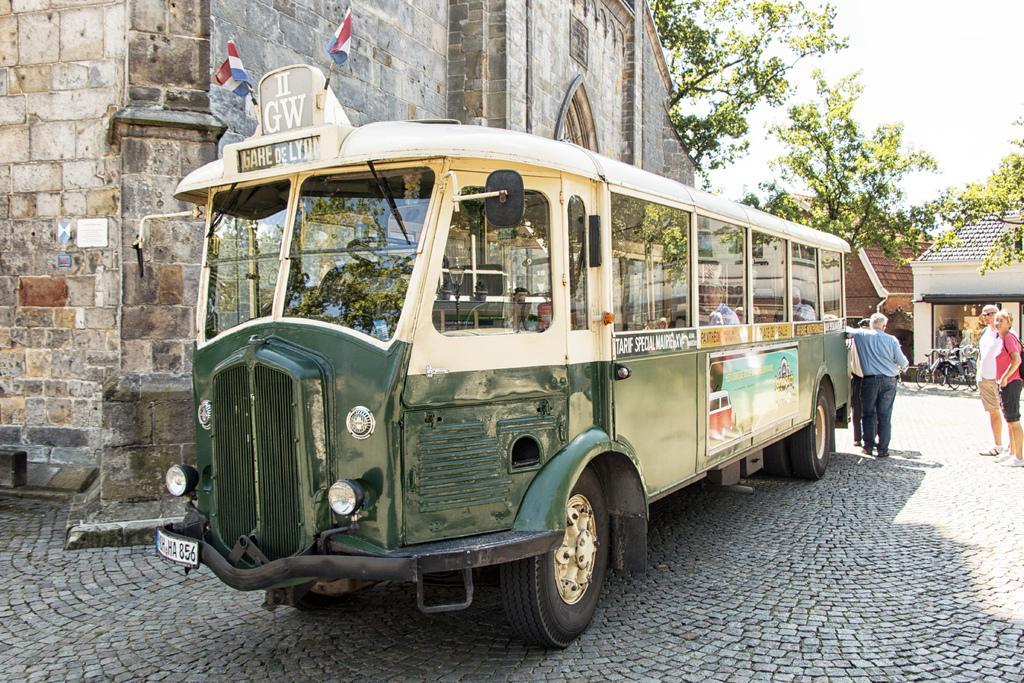Describe this image in one or two sentences. There is a bus. On the bus there are windows, banners, number plate and flags. Inside the bus few people are sitting. Near to the bus few people are standing. Also there is a building with brick wall. In the background there are trees, buildings and sky. 